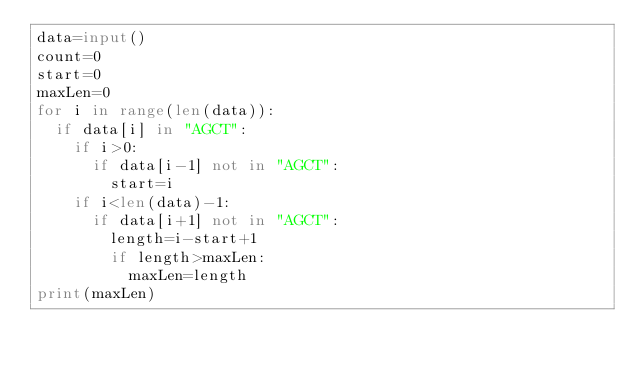<code> <loc_0><loc_0><loc_500><loc_500><_Python_>data=input()
count=0
start=0
maxLen=0
for i in range(len(data)):
  if data[i] in "AGCT":
    if i>0:
      if data[i-1] not in "AGCT":
        start=i
    if i<len(data)-1:
      if data[i+1] not in "AGCT":
        length=i-start+1
        if length>maxLen:
          maxLen=length
print(maxLen)
      
      </code> 